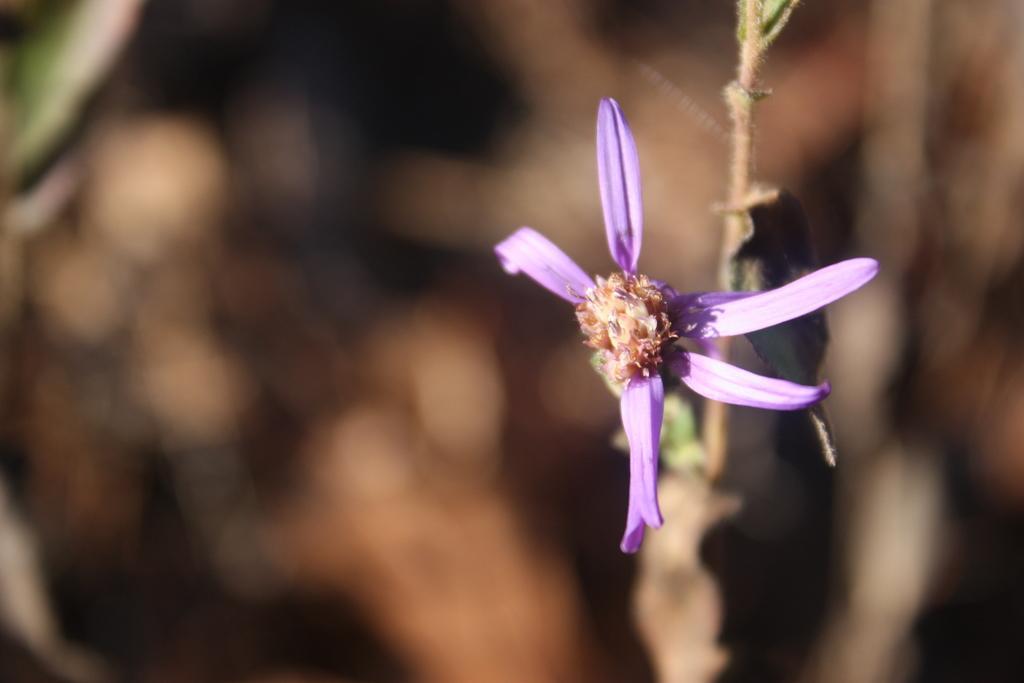Describe this image in one or two sentences. In this image we can see a flower which is in violet color and the background image is blur. 